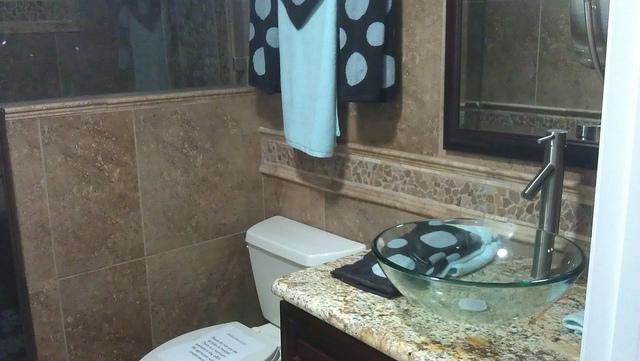Is the sink see-through?
Give a very brief answer. Yes. Does the towel on the vanity match any of the ones hanging?
Concise answer only. Yes. Is water running?
Be succinct. No. 